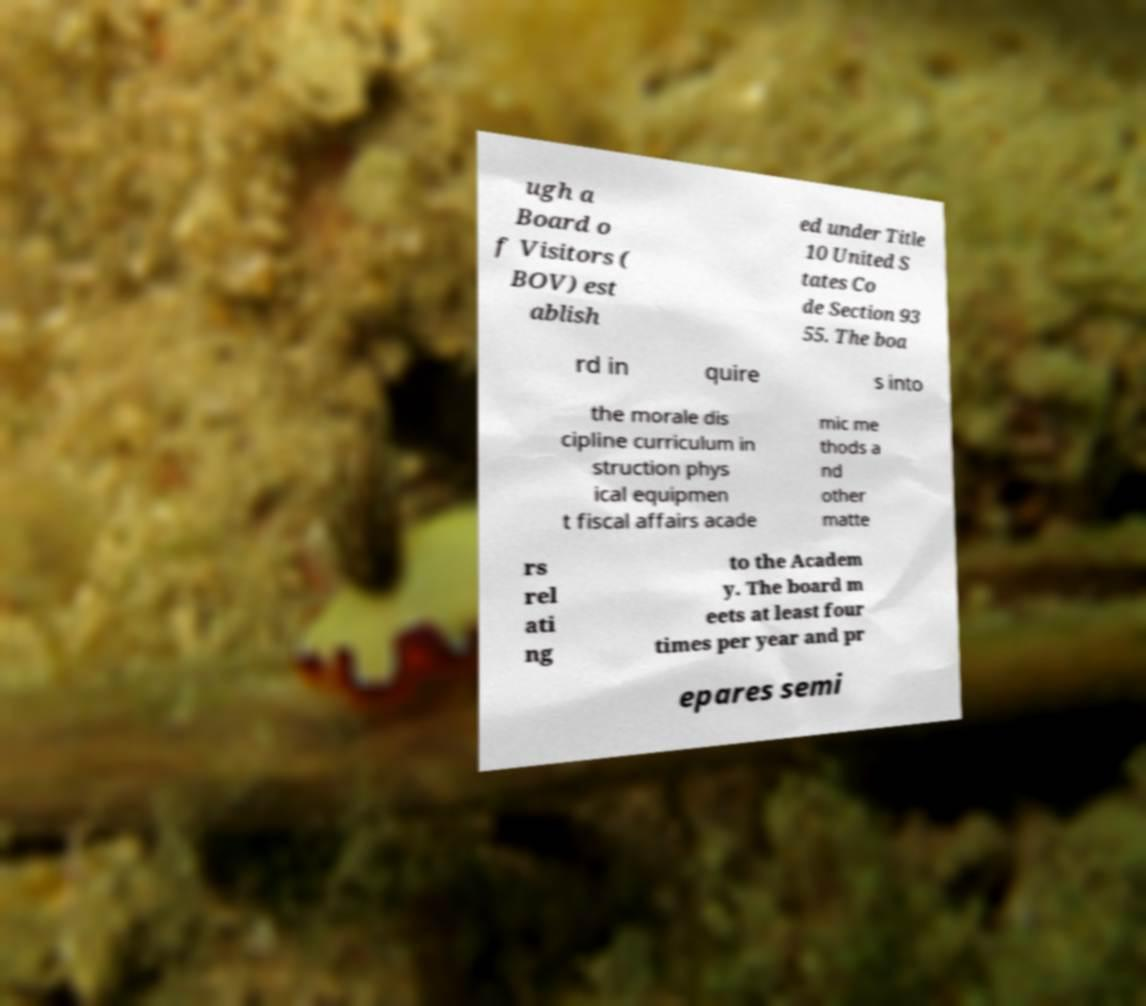Could you extract and type out the text from this image? ugh a Board o f Visitors ( BOV) est ablish ed under Title 10 United S tates Co de Section 93 55. The boa rd in quire s into the morale dis cipline curriculum in struction phys ical equipmen t fiscal affairs acade mic me thods a nd other matte rs rel ati ng to the Academ y. The board m eets at least four times per year and pr epares semi 